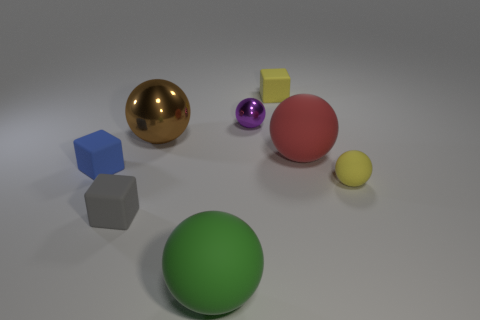Add 1 large green balls. How many objects exist? 9 Subtract all cubes. How many objects are left? 5 Subtract all tiny metallic balls. Subtract all small yellow matte balls. How many objects are left? 6 Add 2 metallic spheres. How many metallic spheres are left? 4 Add 1 tiny spheres. How many tiny spheres exist? 3 Subtract 1 purple spheres. How many objects are left? 7 